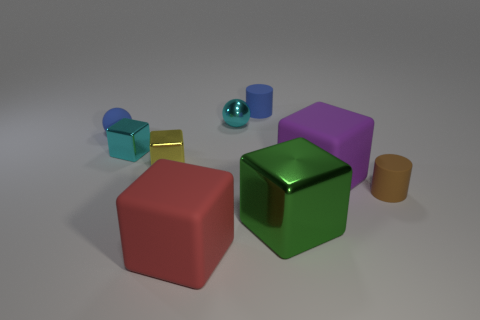Subtract all purple rubber blocks. How many blocks are left? 4 Add 1 small blue rubber cylinders. How many objects exist? 10 Subtract 3 blocks. How many blocks are left? 2 Subtract all balls. How many objects are left? 7 Subtract all cyan cylinders. Subtract all yellow balls. How many cylinders are left? 2 Subtract all red balls. How many red blocks are left? 1 Subtract all big blue shiny cylinders. Subtract all large green objects. How many objects are left? 8 Add 4 small blue things. How many small blue things are left? 6 Add 3 cyan cubes. How many cyan cubes exist? 4 Subtract all cyan spheres. How many spheres are left? 1 